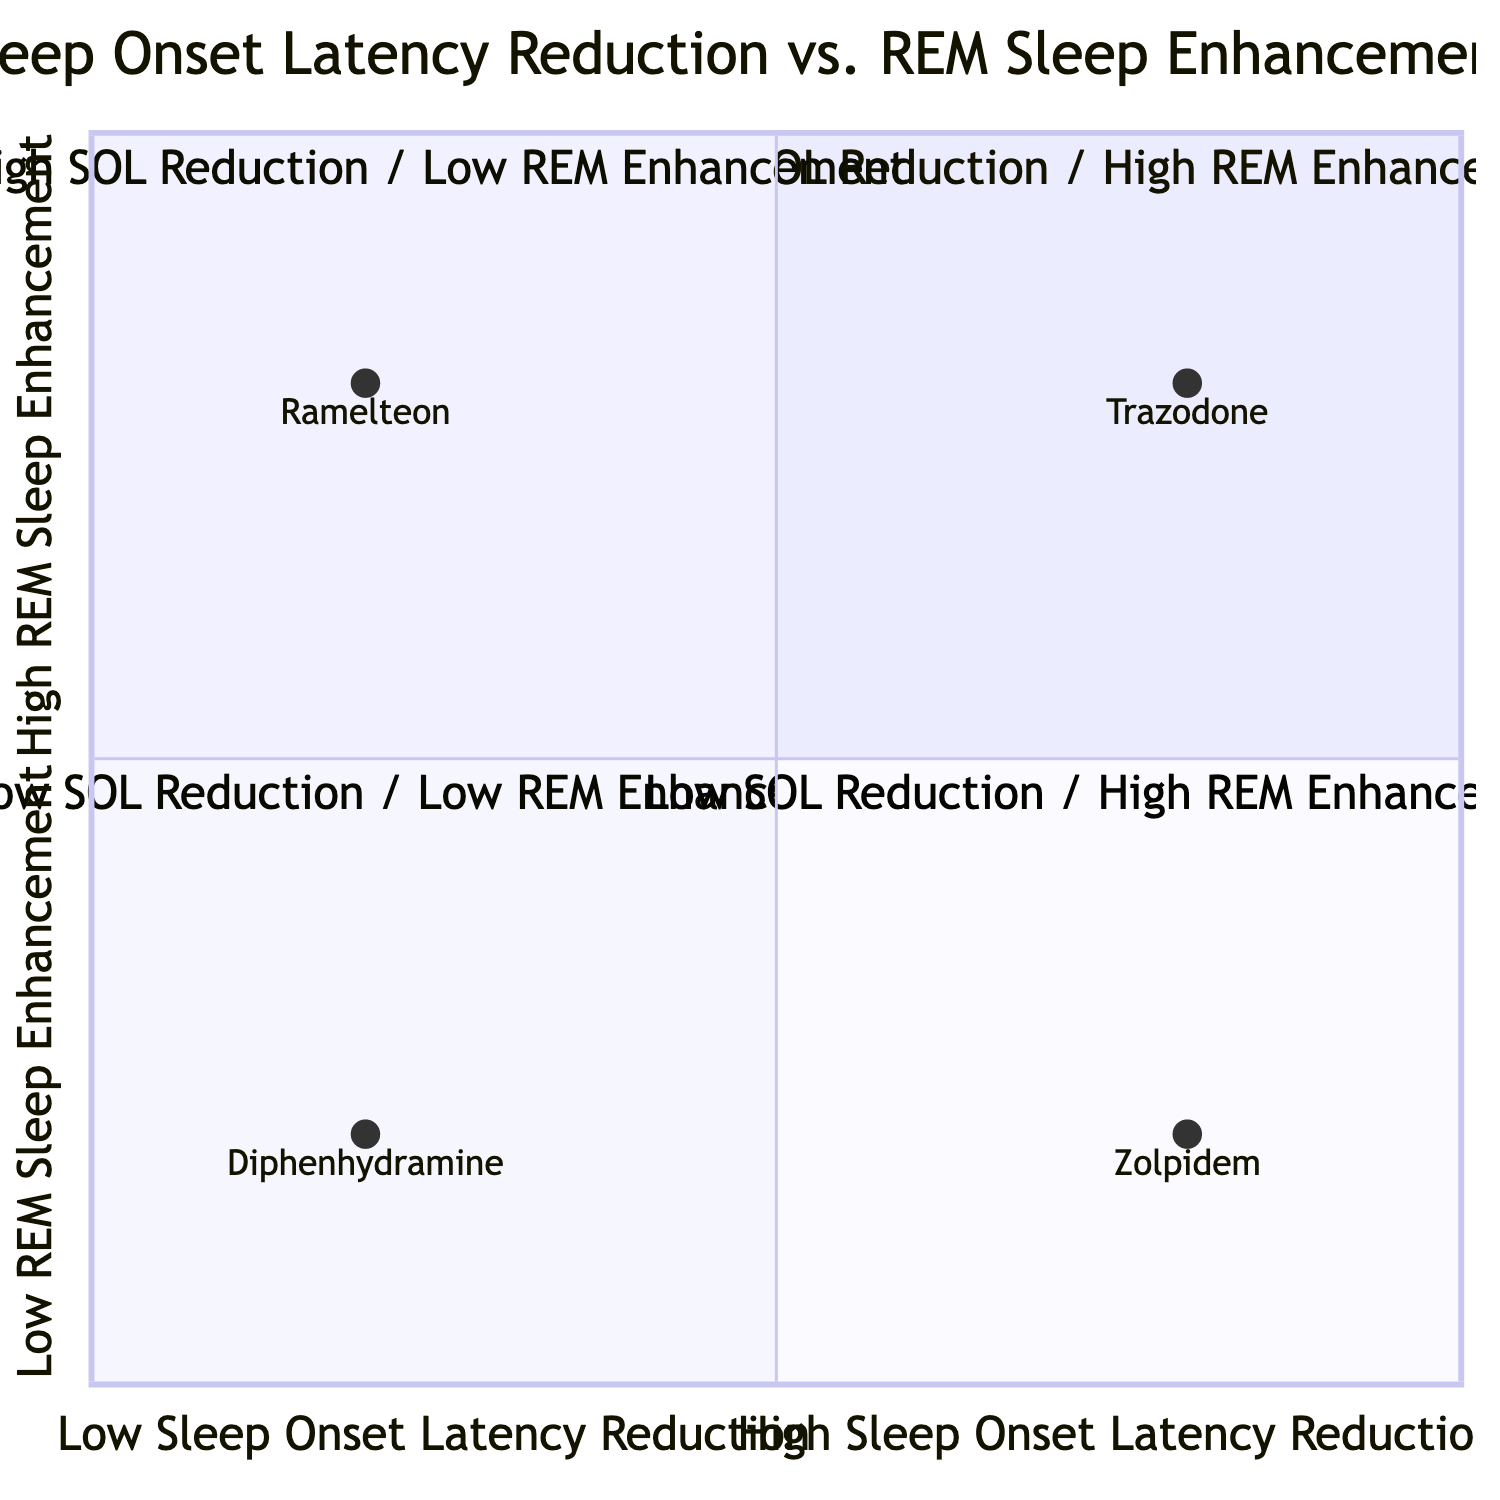What medication is in Quadrant I? Quadrant I is designated for medications that exhibit high sleep onset latency reduction and high REM sleep enhancement. Among the listed medications, Trazodone fits this criterion and is in Quadrant I.
Answer: Trazodone How many medications are represented in Quadrant IV? Quadrant IV consists of medications that have low sleep onset latency reduction and high REM sleep enhancement. From the data, there are no medications that meet these conditions, thus the count is zero.
Answer: 0 Which medication has low sleep onset latency reduction? To find a medication with low sleep onset latency reduction, I review the medications listed under Quadrants III and IV. Both Ramelteon and Diphenhydramine exhibit low sleep onset latency reduction.
Answer: Ramelteon, Diphenhydramine What is the dosage of Zolpidem? The diagram provides specific medication details including their dosage. Looking at Zolpidem, it is indicated to have a dosage of 10 mg.
Answer: 10 mg Which two medications show both high latency reduction and high REM enhancement? I examine each quadrant. Quadrant I has Trazodone that shows both high sleep onset latency reduction and high REM enhancement, as does Quadrant IV. Thus, the two medications in Quadrant I are only Trazodone since no medications are in Quadrant IV meeting the same criteria.
Answer: Trazodone Which medication has the highest REM sleep enhancement? I refer to the medications that show high REM sleep enhancement. Trazodone exhibits high enhancement, while Ramelteon also shows high REM enhancement. Thus the highest noted enhancement is categorized under these medications.
Answer: Trazodone, Ramelteon What does Quadrant II represent? Quadrant II is specifically labeled as high sleep onset latency reduction and low REM sleep enhancement. In this quadrant, only Zolpidem is plotted.
Answer: High Sleep Onset Latency Reduction / Low REM Sleep Enhancement What is the relationship of Diphenhydramine concerning both sleep onset latency reduction and REM enhancement? By evaluating the positioning of Diphenhydramine within the quadrants, it resides in Quadrant III, indicating that it has low sleep onset latency reduction and low REM enhancement.
Answer: Low Sleep Onset Latency Reduction / Low REM Enhancement Which medication type is associated with the highest sleep onset latency reduction? I analyze the quadrant placement respective to sleep onset latency reduction. The medication in the high reduction category is Trazodone, thus it’s evidently associated with the highest reduction.
Answer: Trazodone 